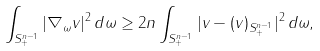<formula> <loc_0><loc_0><loc_500><loc_500>\int _ { S ^ { n - 1 } _ { + } } | \nabla _ { \omega } v | ^ { 2 } \, d \omega \geq 2 n \int _ { S ^ { n - 1 } _ { + } } | v - ( v ) _ { S ^ { n - 1 } _ { + } } | ^ { 2 } \, d \omega ,</formula> 